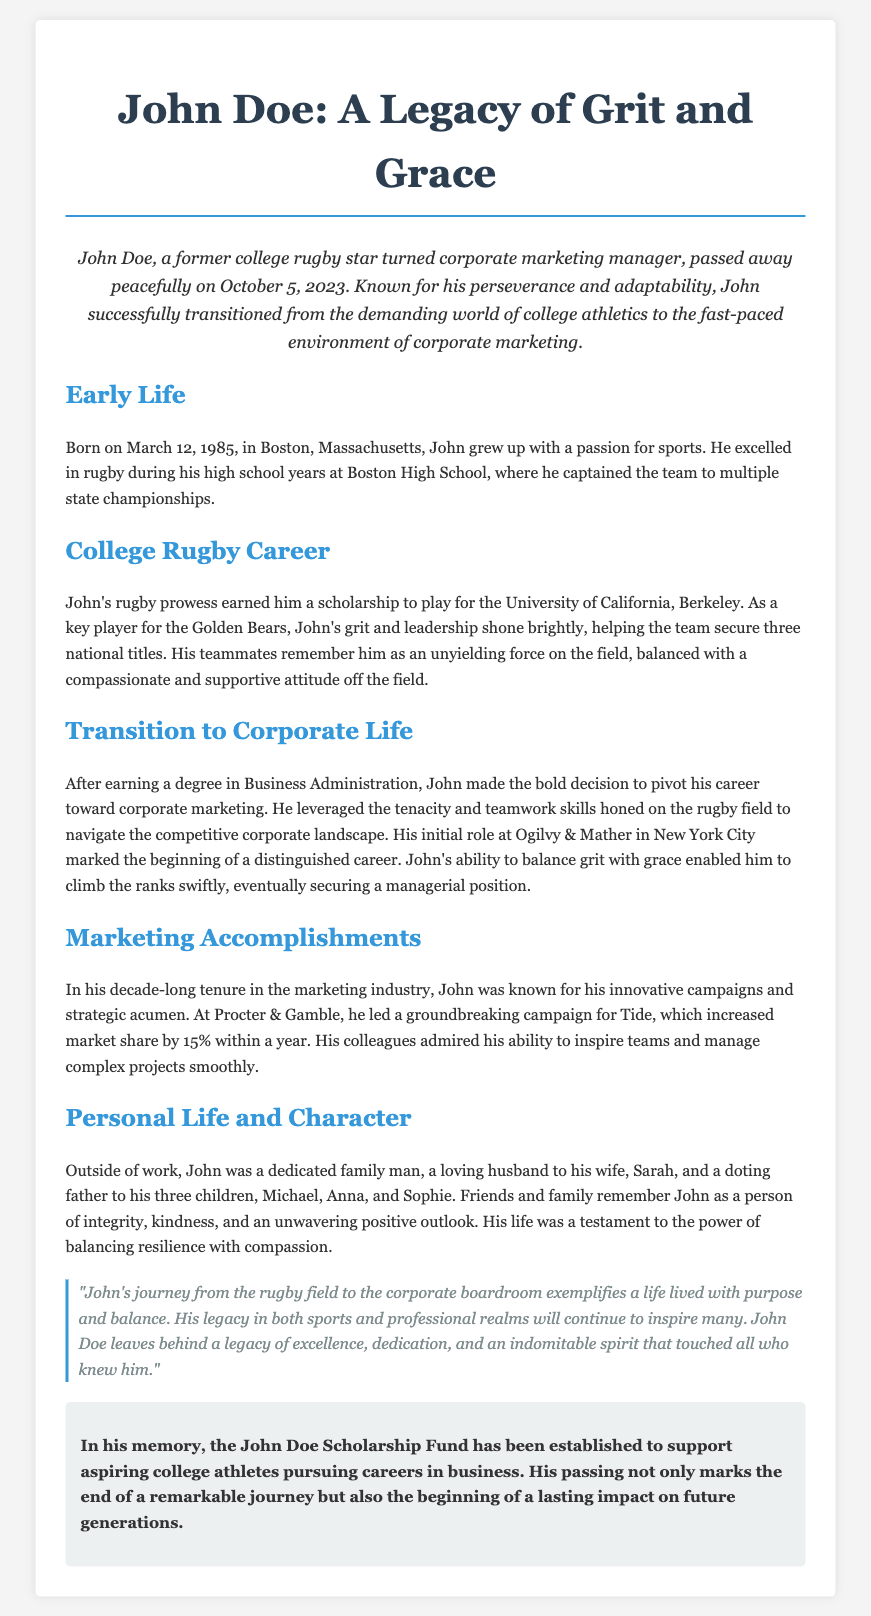What is the full name of the person being remembered? The document states that the individual being remembered is John Doe.
Answer: John Doe When was John Doe born? The document specifies that John Doe was born on March 12, 1985.
Answer: March 12, 1985 What position did John hold at Ogilvy & Mather? The document mentions that John started his career at Ogilvy & Mather but does not specify a position other than his initial role.
Answer: Initial role How many children did John have? The document indicates that John was a father to three children: Michael, Anna, and Sophie.
Answer: Three What sport did John excel in during high school? The document presents that John excelled in rugby during his high school years.
Answer: Rugby How many national titles did John help secure at UC Berkeley? According to the document, John helped his team secure three national titles during his time at UC Berkeley.
Answer: Three What was established in John's memory? The document states that the John Doe Scholarship Fund was established in his memory.
Answer: John Doe Scholarship Fund What personal qualities are attributed to John in the document? The document describes John as a person of integrity, kindness, and an unwavering positive outlook.
Answer: Integrity, kindness, positive outlook What campaign did John lead at Procter & Gamble? The document mentions that John led a groundbreaking campaign for Tide at Procter & Gamble.
Answer: Tide 